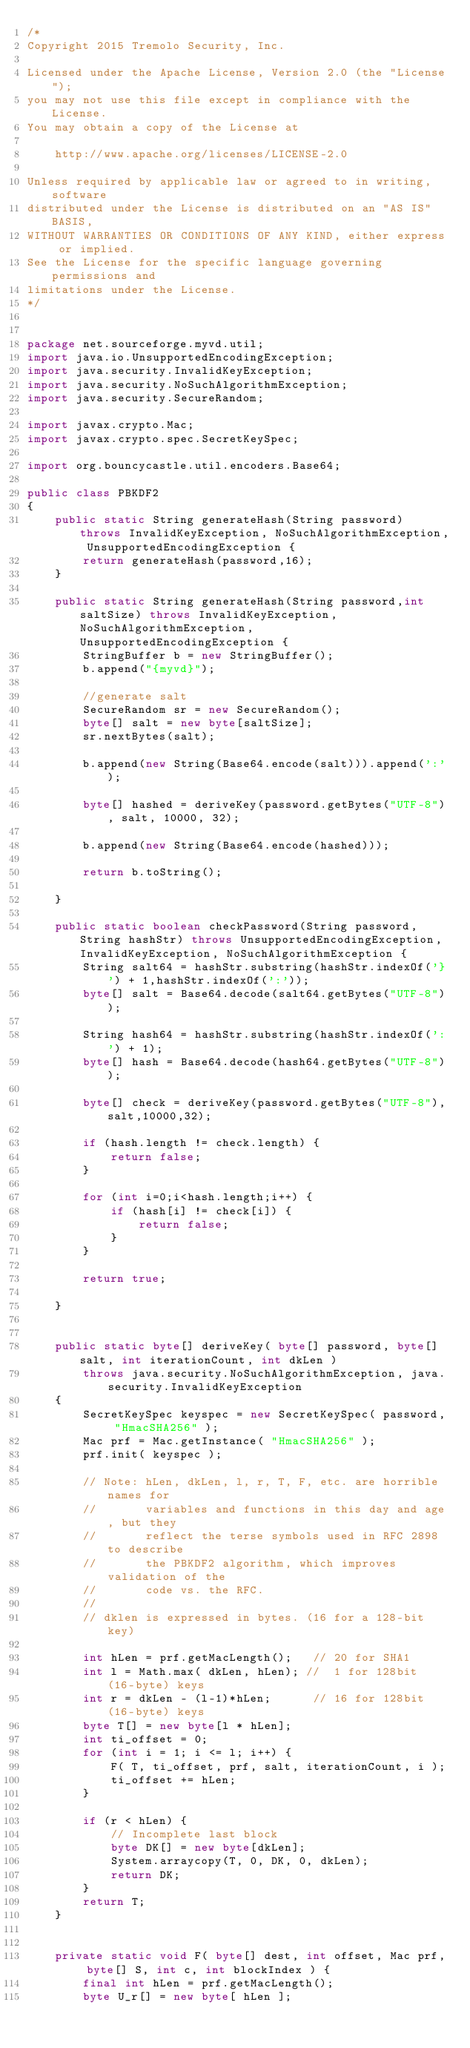<code> <loc_0><loc_0><loc_500><loc_500><_Java_>/*
Copyright 2015 Tremolo Security, Inc.

Licensed under the Apache License, Version 2.0 (the "License");
you may not use this file except in compliance with the License.
You may obtain a copy of the License at

    http://www.apache.org/licenses/LICENSE-2.0

Unless required by applicable law or agreed to in writing, software
distributed under the License is distributed on an "AS IS" BASIS,
WITHOUT WARRANTIES OR CONDITIONS OF ANY KIND, either express or implied.
See the License for the specific language governing permissions and
limitations under the License.
*/


package net.sourceforge.myvd.util;
import java.io.UnsupportedEncodingException;
import java.security.InvalidKeyException;
import java.security.NoSuchAlgorithmException;
import java.security.SecureRandom;

import javax.crypto.Mac;
import javax.crypto.spec.SecretKeySpec;

import org.bouncycastle.util.encoders.Base64;

public class PBKDF2
{
	public static String generateHash(String password) throws InvalidKeyException, NoSuchAlgorithmException, UnsupportedEncodingException {
		return generateHash(password,16);
	}
	
	public static String generateHash(String password,int saltSize) throws InvalidKeyException, NoSuchAlgorithmException, UnsupportedEncodingException {
		StringBuffer b = new StringBuffer();
		b.append("{myvd}");
		
		//generate salt
		SecureRandom sr = new SecureRandom();
		byte[] salt = new byte[saltSize];
		sr.nextBytes(salt);
		
		b.append(new String(Base64.encode(salt))).append(':');
		
		byte[] hashed = deriveKey(password.getBytes("UTF-8"), salt, 10000, 32);
		
		b.append(new String(Base64.encode(hashed)));
		
		return b.toString();
		
	}
	
	public static boolean checkPassword(String password,String hashStr) throws UnsupportedEncodingException, InvalidKeyException, NoSuchAlgorithmException {
		String salt64 = hashStr.substring(hashStr.indexOf('}') + 1,hashStr.indexOf(':'));
		byte[] salt = Base64.decode(salt64.getBytes("UTF-8"));
	
		String hash64 = hashStr.substring(hashStr.indexOf(':') + 1);
		byte[] hash = Base64.decode(hash64.getBytes("UTF-8"));
		
		byte[] check = deriveKey(password.getBytes("UTF-8"),salt,10000,32);
		
		if (hash.length != check.length) {
			return false;
		}
		
		for (int i=0;i<hash.length;i++) {
			if (hash[i] != check[i]) {
				return false;
			}
		}
		
		return true;
		
	}
	
	
    public static byte[] deriveKey( byte[] password, byte[] salt, int iterationCount, int dkLen )
        throws java.security.NoSuchAlgorithmException, java.security.InvalidKeyException
    {
        SecretKeySpec keyspec = new SecretKeySpec( password, "HmacSHA256" );
        Mac prf = Mac.getInstance( "HmacSHA256" );
        prf.init( keyspec );

        // Note: hLen, dkLen, l, r, T, F, etc. are horrible names for
        //       variables and functions in this day and age, but they
        //       reflect the terse symbols used in RFC 2898 to describe
        //       the PBKDF2 algorithm, which improves validation of the
        //       code vs. the RFC.
        //
        // dklen is expressed in bytes. (16 for a 128-bit key)

        int hLen = prf.getMacLength();   // 20 for SHA1
        int l = Math.max( dkLen, hLen); //  1 for 128bit (16-byte) keys
        int r = dkLen - (l-1)*hLen;      // 16 for 128bit (16-byte) keys
        byte T[] = new byte[l * hLen];
        int ti_offset = 0;
        for (int i = 1; i <= l; i++) {
            F( T, ti_offset, prf, salt, iterationCount, i );
            ti_offset += hLen;
        }

        if (r < hLen) {
            // Incomplete last block
            byte DK[] = new byte[dkLen];
            System.arraycopy(T, 0, DK, 0, dkLen);
            return DK;
        }
        return T;
    } 


    private static void F( byte[] dest, int offset, Mac prf, byte[] S, int c, int blockIndex ) {
        final int hLen = prf.getMacLength();
        byte U_r[] = new byte[ hLen ];</code> 